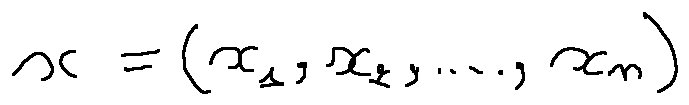<formula> <loc_0><loc_0><loc_500><loc_500>x = ( x _ { 1 } , x _ { 2 } , \dots , x _ { n } )</formula> 